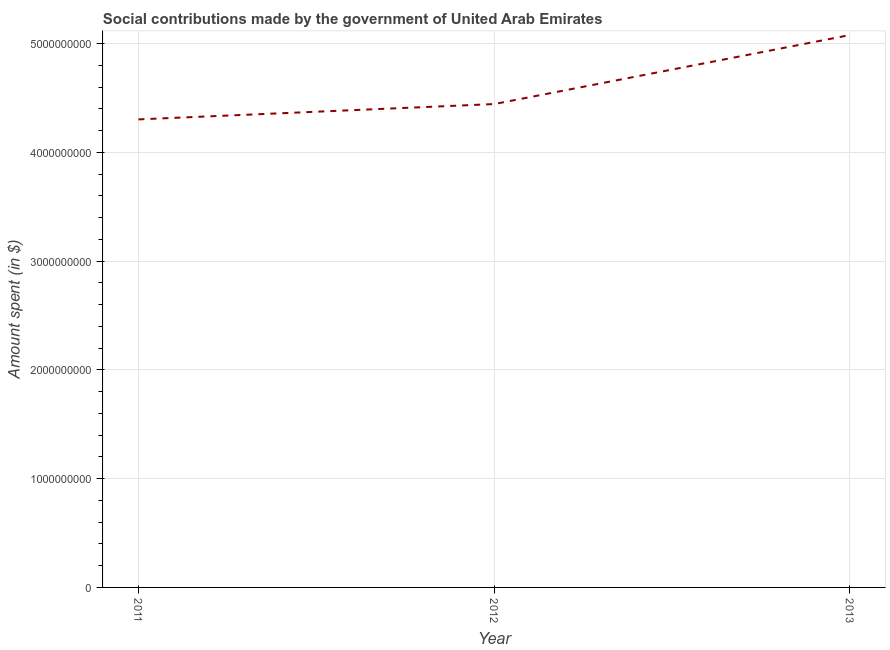What is the amount spent in making social contributions in 2011?
Offer a very short reply. 4.30e+09. Across all years, what is the maximum amount spent in making social contributions?
Provide a short and direct response. 5.08e+09. Across all years, what is the minimum amount spent in making social contributions?
Give a very brief answer. 4.30e+09. What is the sum of the amount spent in making social contributions?
Your answer should be compact. 1.38e+1. What is the difference between the amount spent in making social contributions in 2011 and 2012?
Offer a very short reply. -1.41e+08. What is the average amount spent in making social contributions per year?
Give a very brief answer. 4.61e+09. What is the median amount spent in making social contributions?
Ensure brevity in your answer.  4.44e+09. What is the ratio of the amount spent in making social contributions in 2011 to that in 2013?
Your response must be concise. 0.85. What is the difference between the highest and the second highest amount spent in making social contributions?
Ensure brevity in your answer.  6.35e+08. Is the sum of the amount spent in making social contributions in 2011 and 2012 greater than the maximum amount spent in making social contributions across all years?
Make the answer very short. Yes. What is the difference between the highest and the lowest amount spent in making social contributions?
Keep it short and to the point. 7.76e+08. In how many years, is the amount spent in making social contributions greater than the average amount spent in making social contributions taken over all years?
Offer a very short reply. 1. How many lines are there?
Offer a terse response. 1. How many years are there in the graph?
Offer a very short reply. 3. What is the difference between two consecutive major ticks on the Y-axis?
Provide a succinct answer. 1.00e+09. Does the graph contain any zero values?
Offer a terse response. No. Does the graph contain grids?
Offer a very short reply. Yes. What is the title of the graph?
Your answer should be compact. Social contributions made by the government of United Arab Emirates. What is the label or title of the Y-axis?
Make the answer very short. Amount spent (in $). What is the Amount spent (in $) of 2011?
Make the answer very short. 4.30e+09. What is the Amount spent (in $) in 2012?
Give a very brief answer. 4.44e+09. What is the Amount spent (in $) in 2013?
Provide a succinct answer. 5.08e+09. What is the difference between the Amount spent (in $) in 2011 and 2012?
Provide a succinct answer. -1.41e+08. What is the difference between the Amount spent (in $) in 2011 and 2013?
Offer a terse response. -7.76e+08. What is the difference between the Amount spent (in $) in 2012 and 2013?
Ensure brevity in your answer.  -6.35e+08. What is the ratio of the Amount spent (in $) in 2011 to that in 2013?
Give a very brief answer. 0.85. 